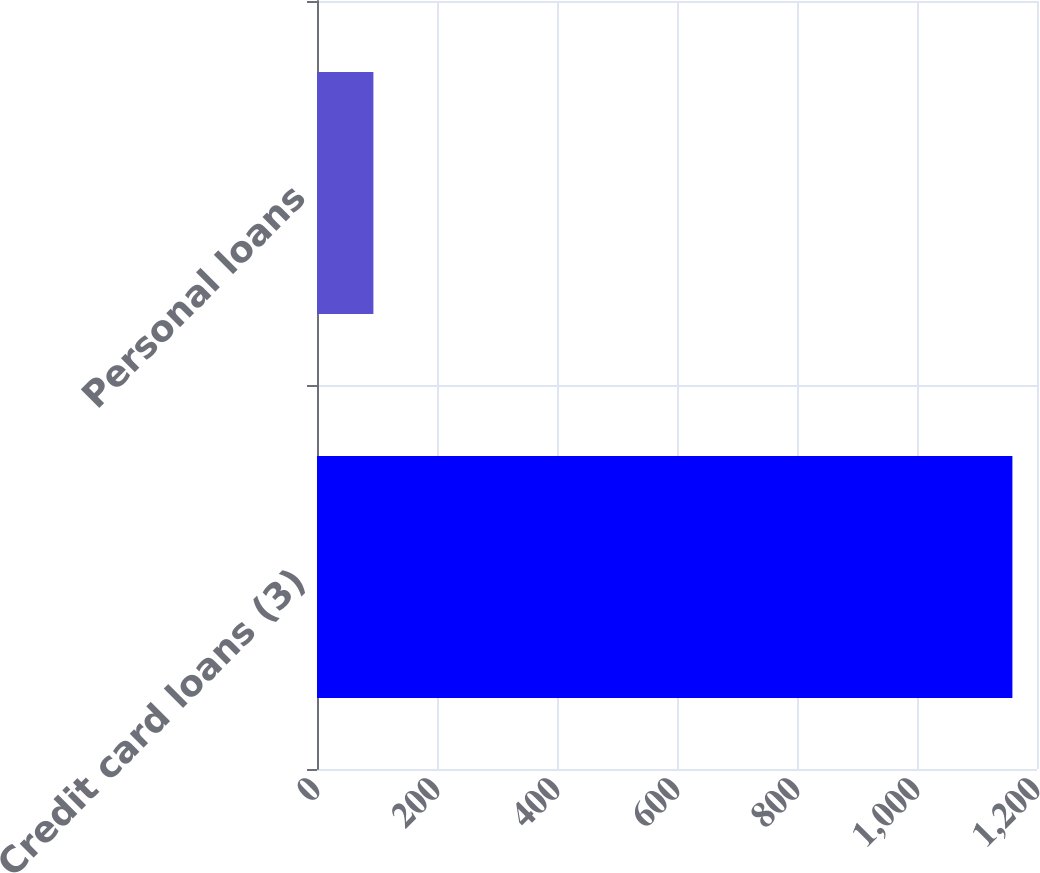<chart> <loc_0><loc_0><loc_500><loc_500><bar_chart><fcel>Credit card loans (3)<fcel>Personal loans<nl><fcel>1159<fcel>94<nl></chart> 